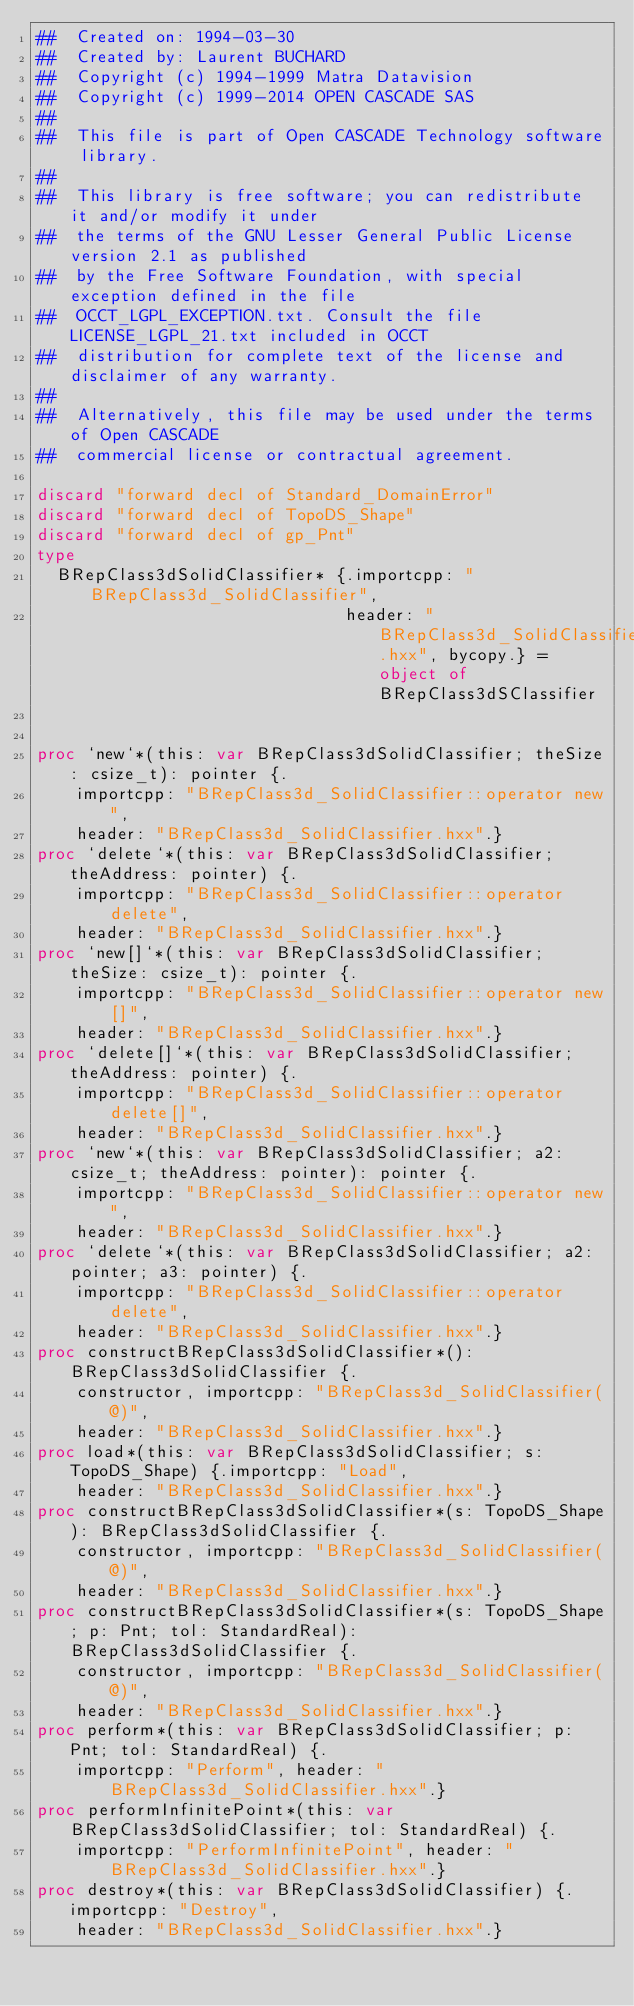Convert code to text. <code><loc_0><loc_0><loc_500><loc_500><_Nim_>##  Created on: 1994-03-30
##  Created by: Laurent BUCHARD
##  Copyright (c) 1994-1999 Matra Datavision
##  Copyright (c) 1999-2014 OPEN CASCADE SAS
##
##  This file is part of Open CASCADE Technology software library.
##
##  This library is free software; you can redistribute it and/or modify it under
##  the terms of the GNU Lesser General Public License version 2.1 as published
##  by the Free Software Foundation, with special exception defined in the file
##  OCCT_LGPL_EXCEPTION.txt. Consult the file LICENSE_LGPL_21.txt included in OCCT
##  distribution for complete text of the license and disclaimer of any warranty.
##
##  Alternatively, this file may be used under the terms of Open CASCADE
##  commercial license or contractual agreement.

discard "forward decl of Standard_DomainError"
discard "forward decl of TopoDS_Shape"
discard "forward decl of gp_Pnt"
type
  BRepClass3dSolidClassifier* {.importcpp: "BRepClass3d_SolidClassifier",
                               header: "BRepClass3d_SolidClassifier.hxx", bycopy.} = object of BRepClass3dSClassifier


proc `new`*(this: var BRepClass3dSolidClassifier; theSize: csize_t): pointer {.
    importcpp: "BRepClass3d_SolidClassifier::operator new",
    header: "BRepClass3d_SolidClassifier.hxx".}
proc `delete`*(this: var BRepClass3dSolidClassifier; theAddress: pointer) {.
    importcpp: "BRepClass3d_SolidClassifier::operator delete",
    header: "BRepClass3d_SolidClassifier.hxx".}
proc `new[]`*(this: var BRepClass3dSolidClassifier; theSize: csize_t): pointer {.
    importcpp: "BRepClass3d_SolidClassifier::operator new[]",
    header: "BRepClass3d_SolidClassifier.hxx".}
proc `delete[]`*(this: var BRepClass3dSolidClassifier; theAddress: pointer) {.
    importcpp: "BRepClass3d_SolidClassifier::operator delete[]",
    header: "BRepClass3d_SolidClassifier.hxx".}
proc `new`*(this: var BRepClass3dSolidClassifier; a2: csize_t; theAddress: pointer): pointer {.
    importcpp: "BRepClass3d_SolidClassifier::operator new",
    header: "BRepClass3d_SolidClassifier.hxx".}
proc `delete`*(this: var BRepClass3dSolidClassifier; a2: pointer; a3: pointer) {.
    importcpp: "BRepClass3d_SolidClassifier::operator delete",
    header: "BRepClass3d_SolidClassifier.hxx".}
proc constructBRepClass3dSolidClassifier*(): BRepClass3dSolidClassifier {.
    constructor, importcpp: "BRepClass3d_SolidClassifier(@)",
    header: "BRepClass3d_SolidClassifier.hxx".}
proc load*(this: var BRepClass3dSolidClassifier; s: TopoDS_Shape) {.importcpp: "Load",
    header: "BRepClass3d_SolidClassifier.hxx".}
proc constructBRepClass3dSolidClassifier*(s: TopoDS_Shape): BRepClass3dSolidClassifier {.
    constructor, importcpp: "BRepClass3d_SolidClassifier(@)",
    header: "BRepClass3d_SolidClassifier.hxx".}
proc constructBRepClass3dSolidClassifier*(s: TopoDS_Shape; p: Pnt; tol: StandardReal): BRepClass3dSolidClassifier {.
    constructor, importcpp: "BRepClass3d_SolidClassifier(@)",
    header: "BRepClass3d_SolidClassifier.hxx".}
proc perform*(this: var BRepClass3dSolidClassifier; p: Pnt; tol: StandardReal) {.
    importcpp: "Perform", header: "BRepClass3d_SolidClassifier.hxx".}
proc performInfinitePoint*(this: var BRepClass3dSolidClassifier; tol: StandardReal) {.
    importcpp: "PerformInfinitePoint", header: "BRepClass3d_SolidClassifier.hxx".}
proc destroy*(this: var BRepClass3dSolidClassifier) {.importcpp: "Destroy",
    header: "BRepClass3d_SolidClassifier.hxx".}</code> 